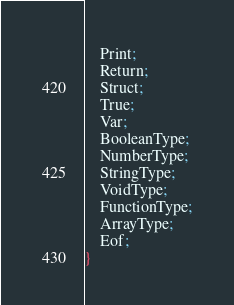Convert code to text. <code><loc_0><loc_0><loc_500><loc_500><_Haxe_>    Print;
    Return;
    Struct;
    True;
    Var;
    BooleanType;
    NumberType;
    StringType;
    VoidType;
    FunctionType;
    ArrayType;
    Eof;
}
</code> 